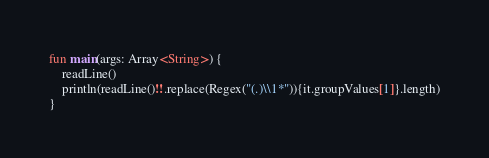<code> <loc_0><loc_0><loc_500><loc_500><_Kotlin_>fun main(args: Array<String>) {
    readLine()
    println(readLine()!!.replace(Regex("(.)\\1*")){it.groupValues[1]}.length)
}</code> 